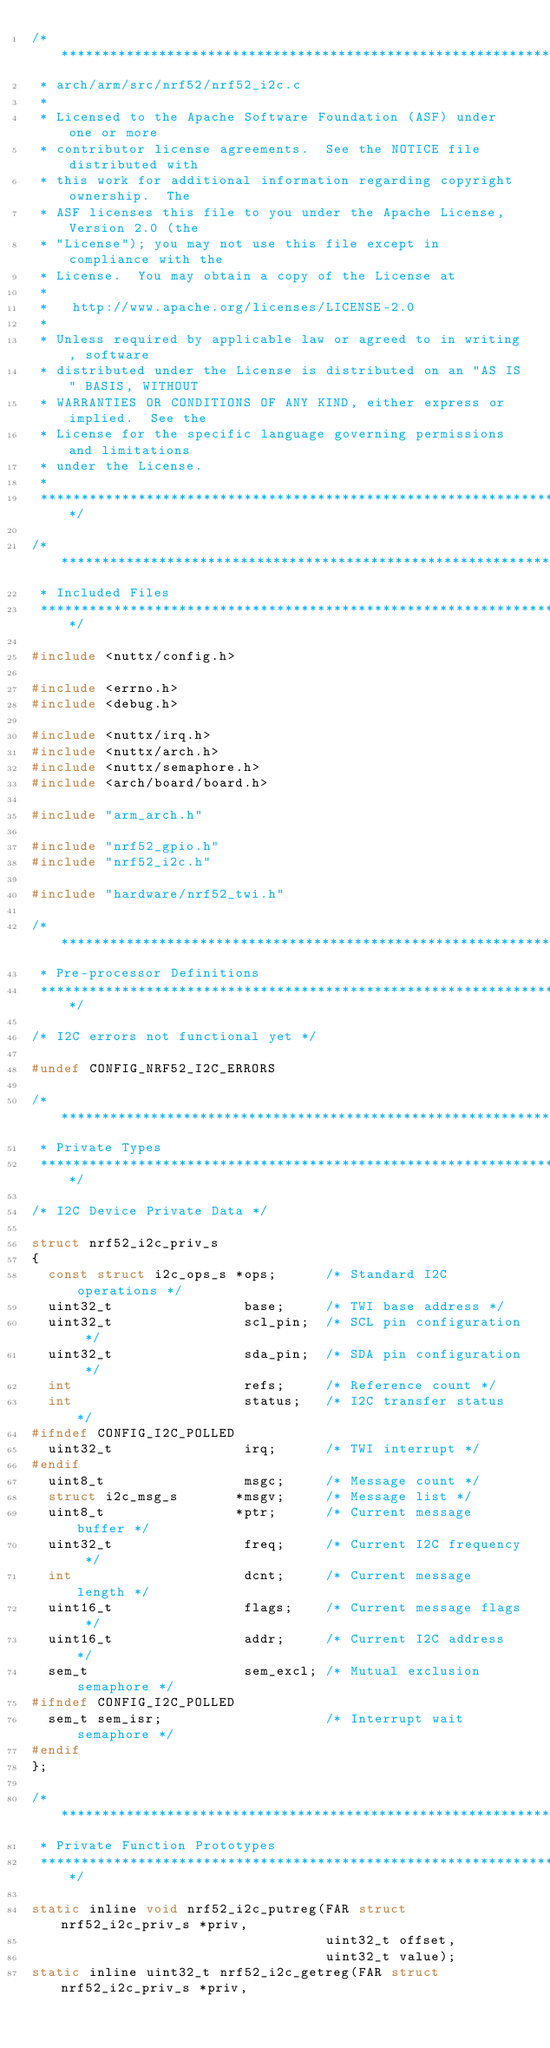Convert code to text. <code><loc_0><loc_0><loc_500><loc_500><_C_>/****************************************************************************
 * arch/arm/src/nrf52/nrf52_i2c.c
 *
 * Licensed to the Apache Software Foundation (ASF) under one or more
 * contributor license agreements.  See the NOTICE file distributed with
 * this work for additional information regarding copyright ownership.  The
 * ASF licenses this file to you under the Apache License, Version 2.0 (the
 * "License"); you may not use this file except in compliance with the
 * License.  You may obtain a copy of the License at
 *
 *   http://www.apache.org/licenses/LICENSE-2.0
 *
 * Unless required by applicable law or agreed to in writing, software
 * distributed under the License is distributed on an "AS IS" BASIS, WITHOUT
 * WARRANTIES OR CONDITIONS OF ANY KIND, either express or implied.  See the
 * License for the specific language governing permissions and limitations
 * under the License.
 *
 ****************************************************************************/

/****************************************************************************
 * Included Files
 ****************************************************************************/

#include <nuttx/config.h>

#include <errno.h>
#include <debug.h>

#include <nuttx/irq.h>
#include <nuttx/arch.h>
#include <nuttx/semaphore.h>
#include <arch/board/board.h>

#include "arm_arch.h"

#include "nrf52_gpio.h"
#include "nrf52_i2c.h"

#include "hardware/nrf52_twi.h"

/****************************************************************************
 * Pre-processor Definitions
 ****************************************************************************/

/* I2C errors not functional yet */

#undef CONFIG_NRF52_I2C_ERRORS

/****************************************************************************
 * Private Types
 ****************************************************************************/

/* I2C Device Private Data */

struct nrf52_i2c_priv_s
{
  const struct i2c_ops_s *ops;      /* Standard I2C operations */
  uint32_t                base;     /* TWI base address */
  uint32_t                scl_pin;  /* SCL pin configuration */
  uint32_t                sda_pin;  /* SDA pin configuration */
  int                     refs;     /* Reference count */
  int                     status;   /* I2C transfer status */
#ifndef CONFIG_I2C_POLLED
  uint32_t                irq;      /* TWI interrupt */
#endif
  uint8_t                 msgc;     /* Message count */
  struct i2c_msg_s       *msgv;     /* Message list */
  uint8_t                *ptr;      /* Current message buffer */
  uint32_t                freq;     /* Current I2C frequency */
  int                     dcnt;     /* Current message length */
  uint16_t                flags;    /* Current message flags */
  uint16_t                addr;     /* Current I2C address */
  sem_t                   sem_excl; /* Mutual exclusion semaphore */
#ifndef CONFIG_I2C_POLLED
  sem_t sem_isr;                    /* Interrupt wait semaphore */
#endif
};

/****************************************************************************
 * Private Function Prototypes
 ****************************************************************************/

static inline void nrf52_i2c_putreg(FAR struct nrf52_i2c_priv_s *priv,
                                    uint32_t offset,
                                    uint32_t value);
static inline uint32_t nrf52_i2c_getreg(FAR struct nrf52_i2c_priv_s *priv,</code> 